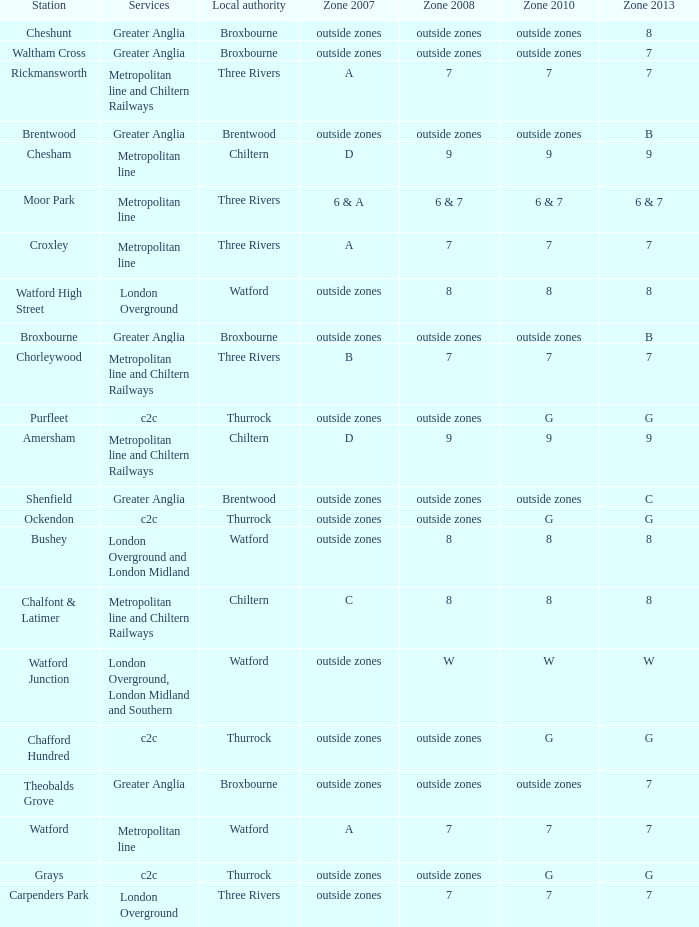Which Zone 2008 has Services of greater anglia, and a Station of cheshunt? Outside zones. 